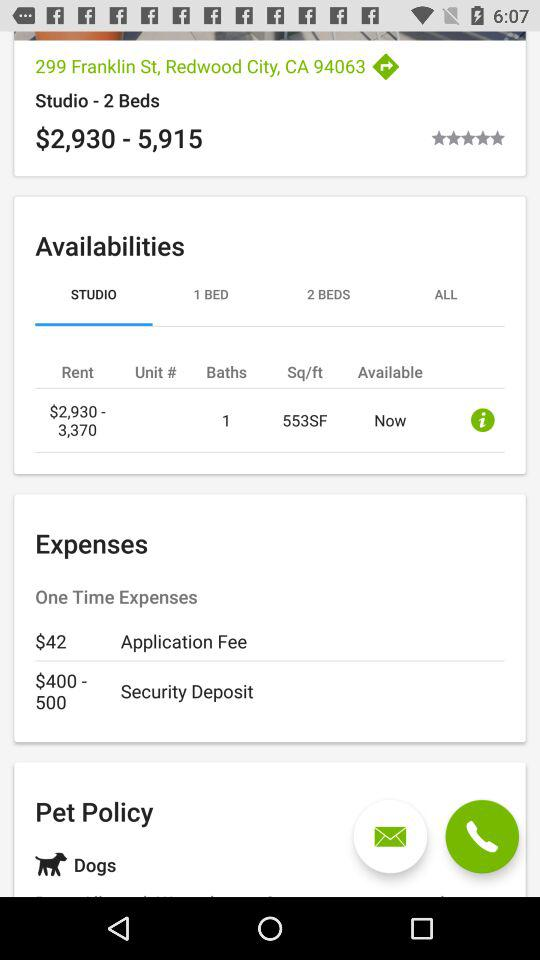What is the security deposit price? The security deposit price is $400-500. 